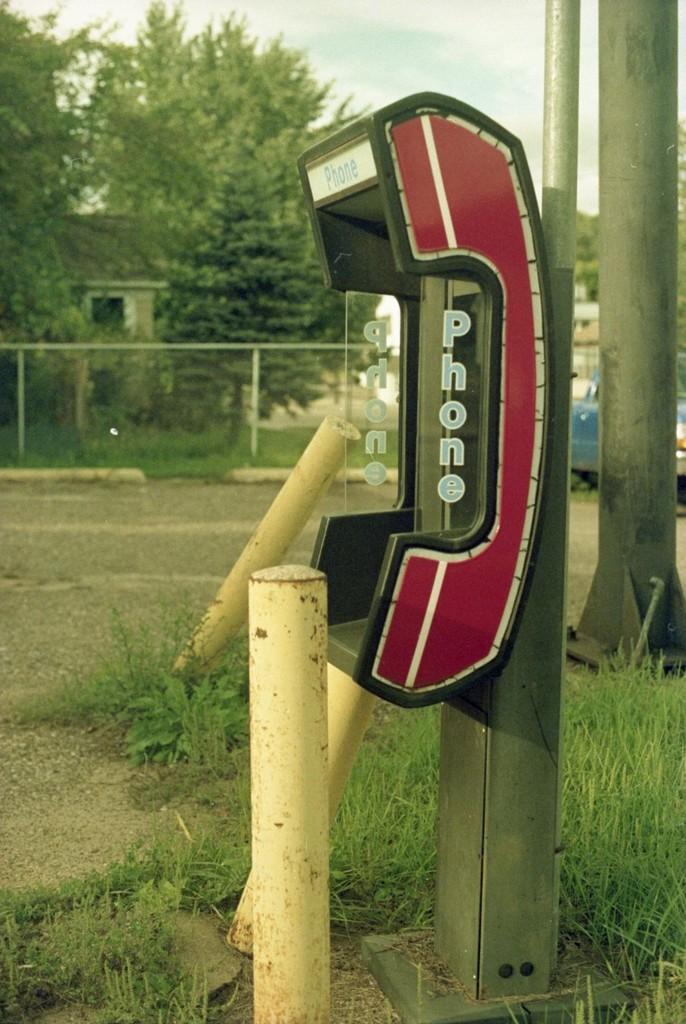Could you give a brief overview of what you see in this image? In this picture we can see a phone booth. Some grass is visible on the ground. We can see some fencing. There are poles, trees and a house in the background. 